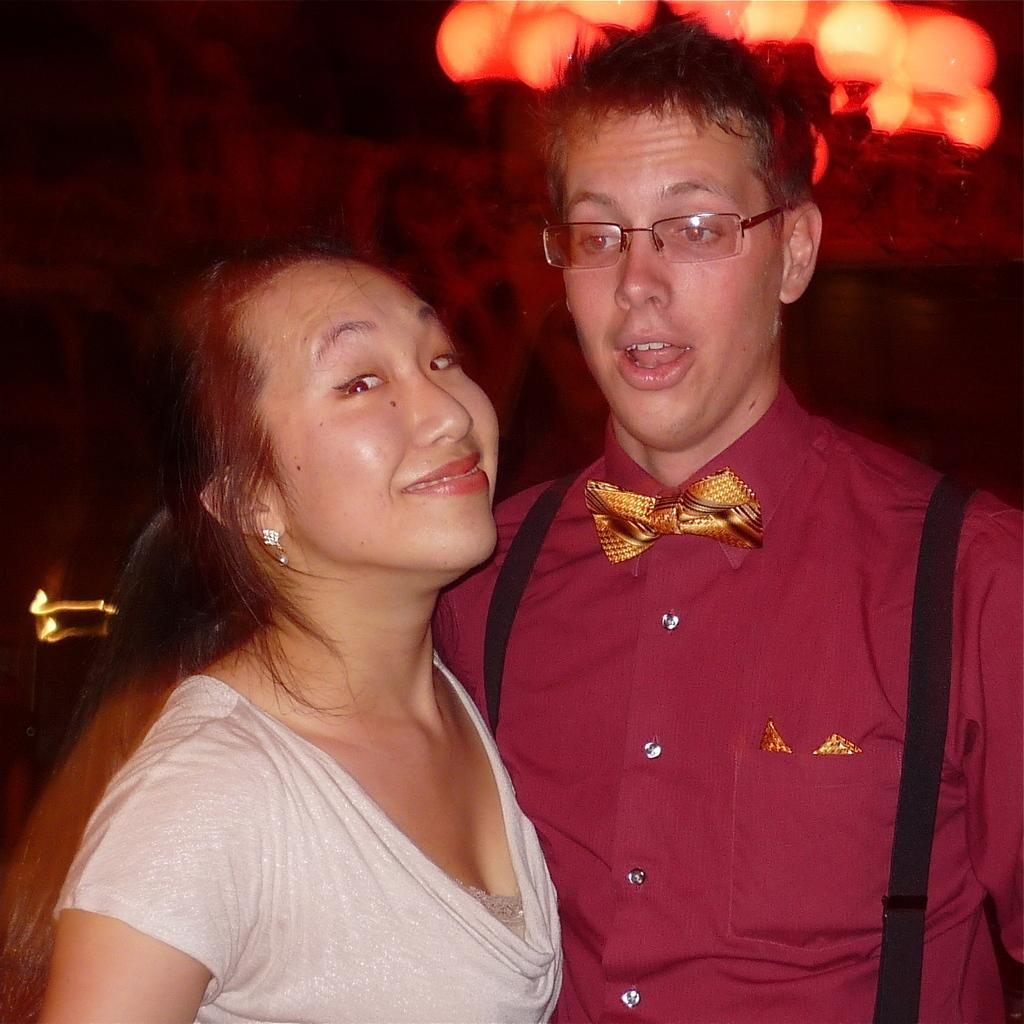Who are the people in the image? There is a man and a woman in the image. What is the woman doing in the image? The woman is smiling in the image. Can you describe the background of the image? The background of the image is blurry. What type of glove is the man wearing in the image? There is no glove visible in the image; the man is not wearing any gloves. 